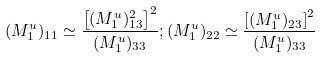<formula> <loc_0><loc_0><loc_500><loc_500>( M _ { 1 } ^ { u } ) _ { 1 1 } \simeq \frac { \left [ ( M _ { 1 } ^ { u } ) ^ { 2 } _ { 1 3 } \right ] ^ { 2 } } { ( M _ { 1 } ^ { u } ) _ { 3 3 } } ; ( M _ { 1 } ^ { u } ) _ { 2 2 } \simeq \frac { \left [ ( M _ { 1 } ^ { u } ) _ { 2 3 } \right ] ^ { 2 } } { ( M _ { 1 } ^ { u } ) _ { 3 3 } }</formula> 